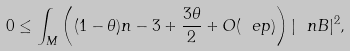<formula> <loc_0><loc_0><loc_500><loc_500>0 \leq \int _ { M } \left ( ( 1 - \theta ) n - 3 + \frac { 3 \theta } { 2 } + O ( \ e p ) \right ) | \ n B | ^ { 2 } ,</formula> 